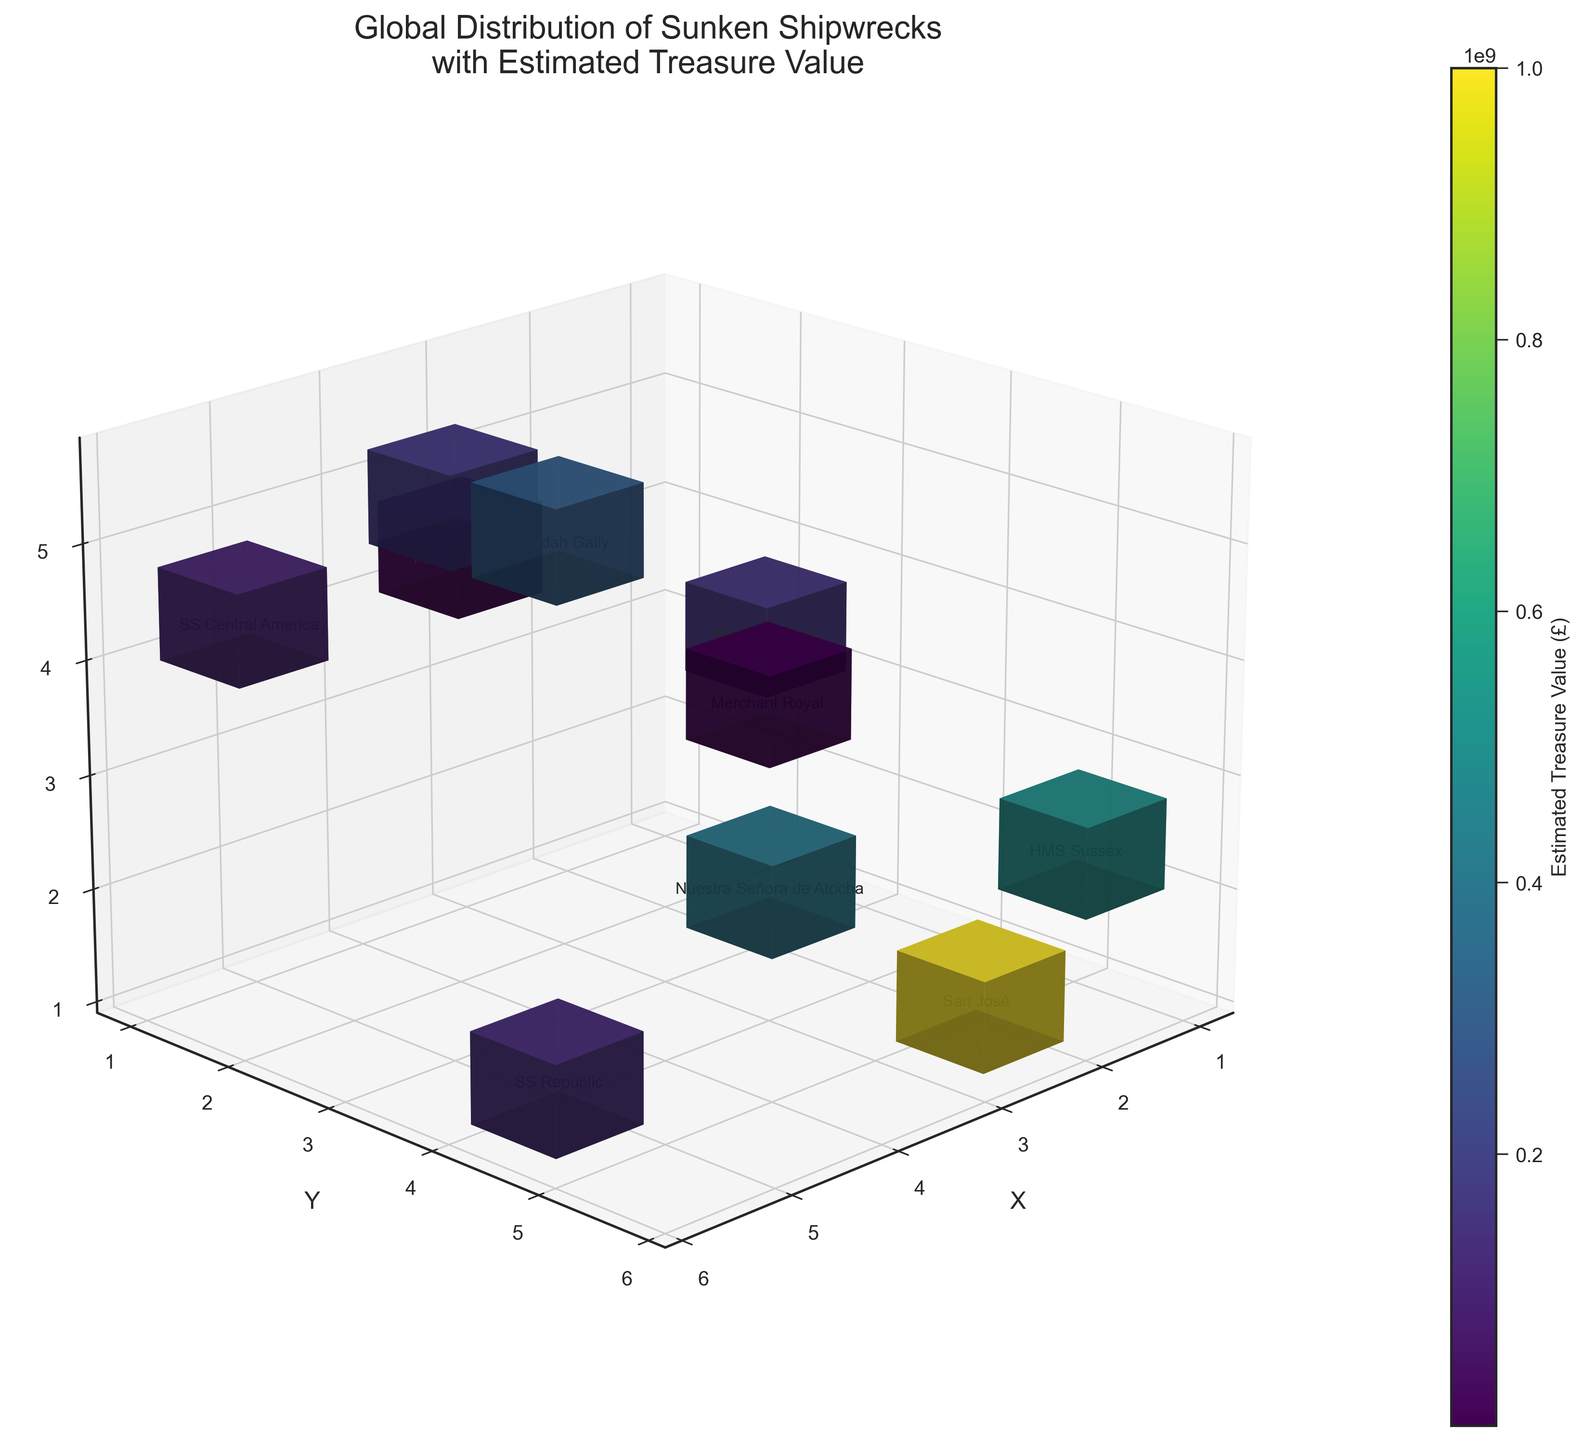What's the title of the plot? The title is often located at the top center of the plot. Reading the plot's title helps in understanding the overall theme and subject of the plot.
Answer: Global Distribution of Sunken Shipwrecks with Estimated Treasure Value Which axis represents the 'X' coordinate? The axes are usually labeled with their respective coordinates. By reading the label at the edge of each axis, we can identify which axis corresponds to 'X'.
Answer: The horizontal axis from the bottom front view Which sunken shipwreck has the highest estimated treasure value? The color mapping on the plot correlates with the estimated treasure value. The shipwreck with the darkest color (indicating the highest value) can be identified to answer this question. Additionally, the plot annotations show the name.
Answer: Flor de la Mar How many shipwrecks are displayed on the plot? Each voxel corresponds to a shipwreck, and counting these voxels gives us the number of shipwrecks depicted in the plot.
Answer: 10 Which shipwrecks are located at the highest Z-coordinate? By examining and comparing the z-coordinate positions of all the voxels, we can determine which shipwrecks have the highest value on the Z-axis. Annotations help identify these shipwrecks.
Answer: Whydah Gally and Le Chameau What is the estimated treasure value of the San José shipwreck? By looking for the annotation closest or on the voxel representing San José (based on the plot annotations), the corresponding color can be matched with the color bar to find the value.
Answer: £1 billion Which axis values are associated with Nuestra Señora de Atocha? The position of each shipwreck on the plot can be observed by the annotations. The point where Nuestra Señora de Atocha is labeled will have x, y, and z values.
Answer: x=3, y=4, z=2 Compare the treasure values of HMS Sussex and SS Central America. Which one is higher? By locating the voxels corresponding to HMS Sussex and SS Central America through their annotations, we can compare their respective colors and match these colors to the color bar to see which value is higher.
Answer: HMS Sussex What are the controversies associated with the Merchant Royal shipwreck? Annotations near the Merchant Royal voxel provide additional data which includes the controversies.
Answer: Unethical excavation methods Find the shipwreck located at coordinates (2, 5, 1). What is its name and estimated treasure value? By observing the voxel at coordinates (2, 5, 1) and reading its annotation, we can find the shipwreck name. Then refer to the color bar to assess its treasure value.
Answer: San José, £1 billion Which shipwreck has controversy related to environmental damage, and where is it located? By identifying shipwreck names first and then referring to the annotations data of controversies, we match to find the location in (x, y, z).
Answer: SS Gairsoppa, located at (1, 2, 3) 